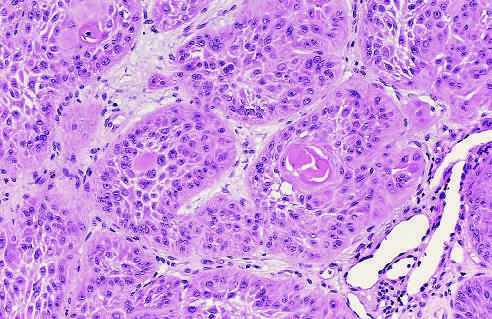what are strikingly similar to normal squamous epithelial cells, with intercellular bridges and nests of keratin?
Answer the question using a single word or phrase. The tumor cells 